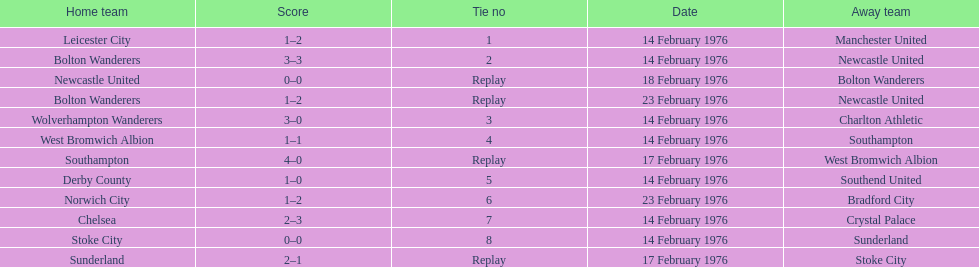How many teams took part on february 14th, 1976? 7. 